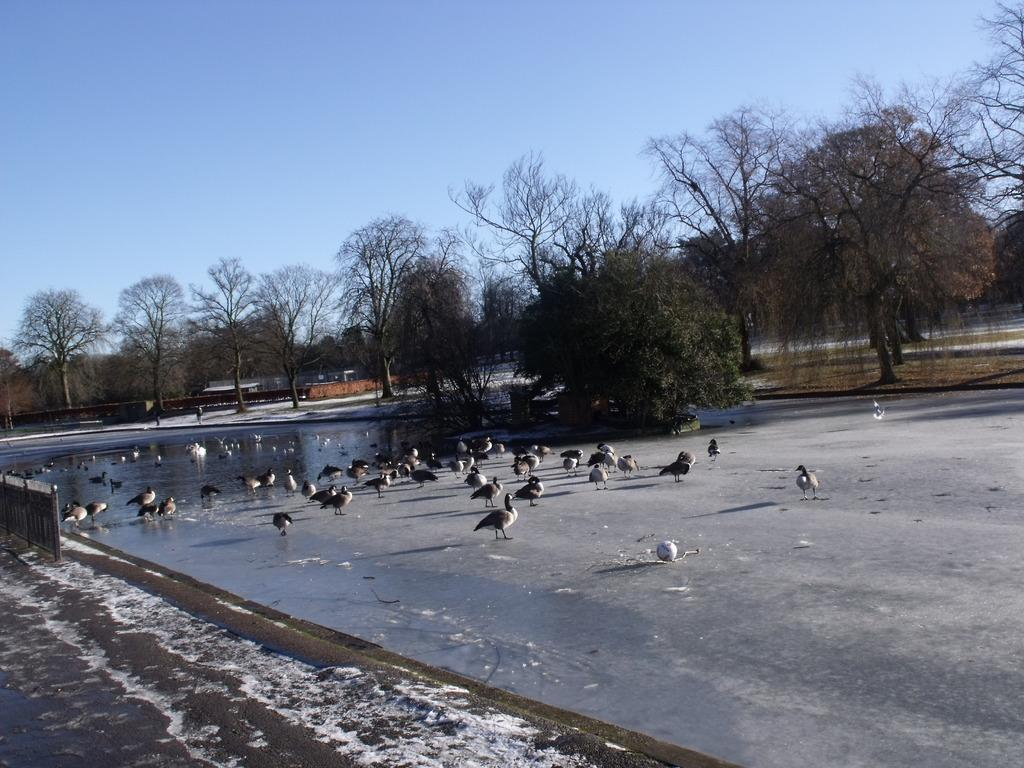What type of animals can be seen in the image? There are birds in the image. What colors are the birds in the image? The birds are in white and black color. What can be seen in the background of the image? There are trees and buildings in the background of the image. What color are the trees in the image? The trees are in green color. What color is the sky in the image? The sky is in blue color. How does the building in the image pull the birds towards it? There is no building present in the image that is pulling the birds towards it. The birds are simply perched on branches or flying in the sky. 